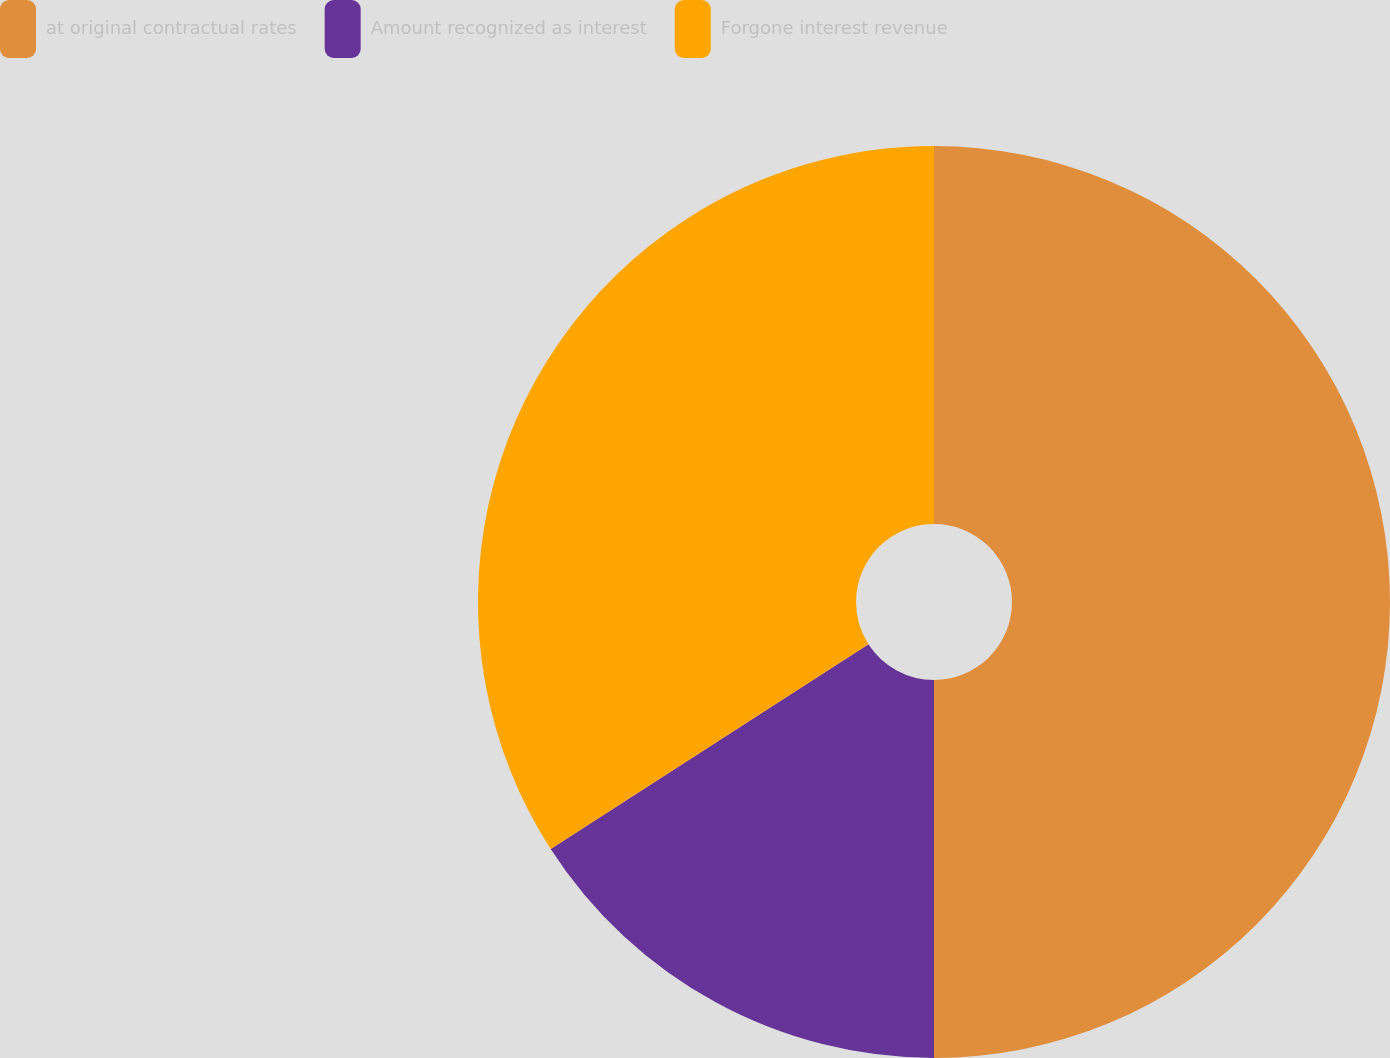Convert chart. <chart><loc_0><loc_0><loc_500><loc_500><pie_chart><fcel>at original contractual rates<fcel>Amount recognized as interest<fcel>Forgone interest revenue<nl><fcel>50.0%<fcel>15.89%<fcel>34.11%<nl></chart> 